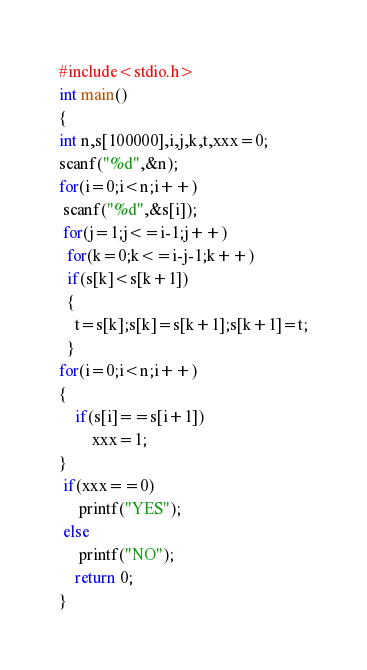Convert code to text. <code><loc_0><loc_0><loc_500><loc_500><_C++_>#include<stdio.h>
int main()
{  
int n,s[100000],i,j,k,t,xxx=0;
scanf("%d",&n);
for(i=0;i<n;i++)
 scanf("%d",&s[i]);
 for(j=1;j<=i-1;j++)
  for(k=0;k<=i-j-1;k++)
  if(s[k]<s[k+1])
  {
	t=s[k];s[k]=s[k+1];s[k+1]=t;
  }
for(i=0;i<n;i++)
{
	if(s[i]==s[i+1])
		xxx=1;
}	 
 if(xxx==0)
	 printf("YES");
 else
	 printf("NO");
    return 0;
}</code> 